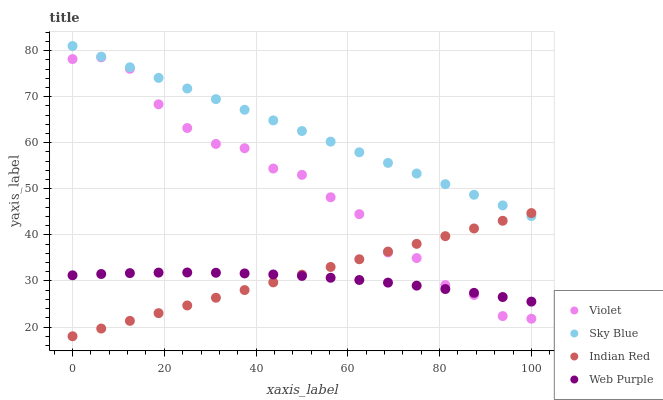Does Web Purple have the minimum area under the curve?
Answer yes or no. Yes. Does Sky Blue have the maximum area under the curve?
Answer yes or no. Yes. Does Indian Red have the minimum area under the curve?
Answer yes or no. No. Does Indian Red have the maximum area under the curve?
Answer yes or no. No. Is Indian Red the smoothest?
Answer yes or no. Yes. Is Violet the roughest?
Answer yes or no. Yes. Is Web Purple the smoothest?
Answer yes or no. No. Is Web Purple the roughest?
Answer yes or no. No. Does Indian Red have the lowest value?
Answer yes or no. Yes. Does Web Purple have the lowest value?
Answer yes or no. No. Does Sky Blue have the highest value?
Answer yes or no. Yes. Does Indian Red have the highest value?
Answer yes or no. No. Is Violet less than Sky Blue?
Answer yes or no. Yes. Is Sky Blue greater than Web Purple?
Answer yes or no. Yes. Does Web Purple intersect Violet?
Answer yes or no. Yes. Is Web Purple less than Violet?
Answer yes or no. No. Is Web Purple greater than Violet?
Answer yes or no. No. Does Violet intersect Sky Blue?
Answer yes or no. No. 